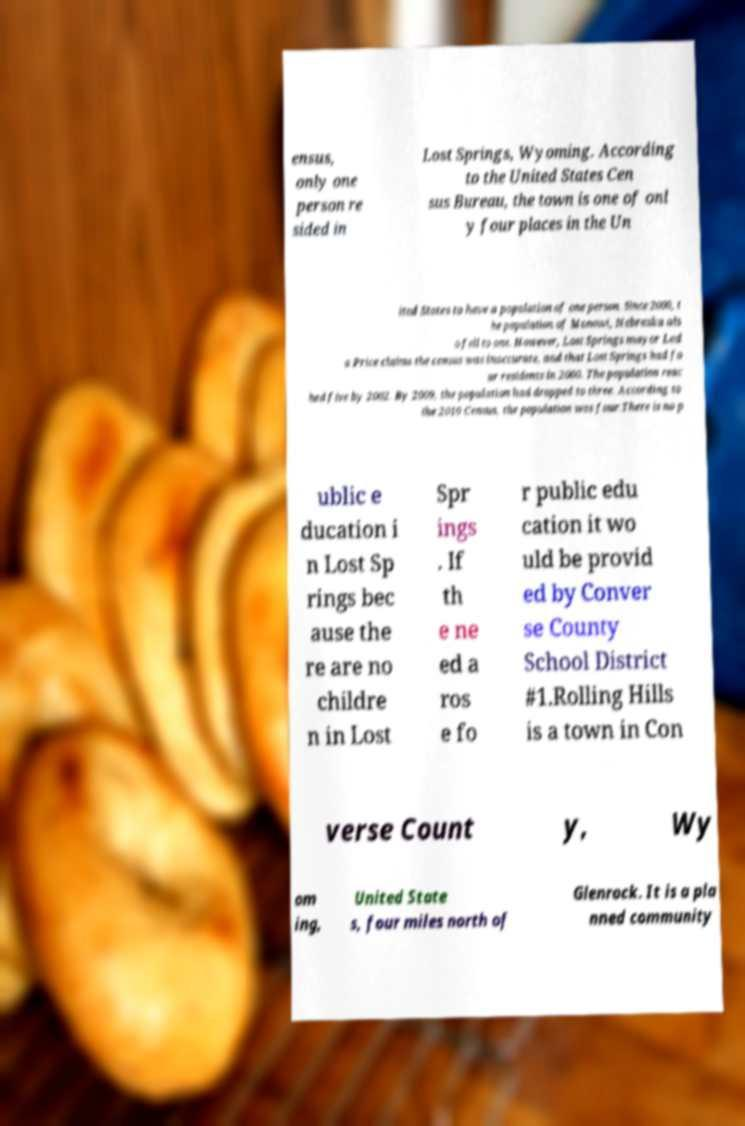Please identify and transcribe the text found in this image. ensus, only one person re sided in Lost Springs, Wyoming. According to the United States Cen sus Bureau, the town is one of onl y four places in the Un ited States to have a population of one person. Since 2000, t he population of Monowi, Nebraska als o fell to one. However, Lost Springs mayor Led a Price claims the census was inaccurate, and that Lost Springs had fo ur residents in 2000. The population reac hed five by 2002. By 2009, the population had dropped to three. According to the 2010 Census, the population was four.There is no p ublic e ducation i n Lost Sp rings bec ause the re are no childre n in Lost Spr ings . If th e ne ed a ros e fo r public edu cation it wo uld be provid ed by Conver se County School District #1.Rolling Hills is a town in Con verse Count y, Wy om ing, United State s, four miles north of Glenrock. It is a pla nned community 